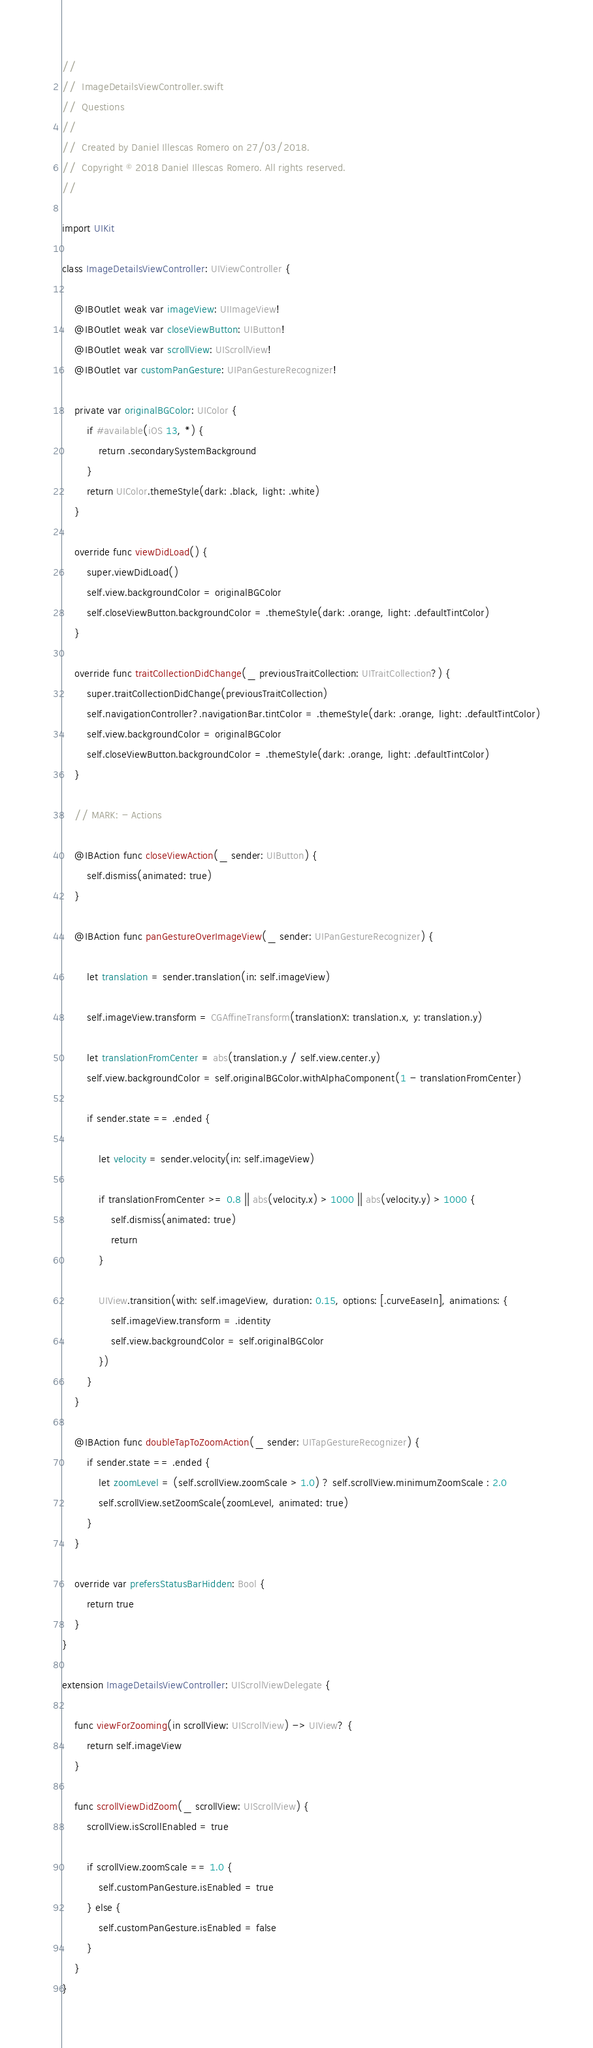<code> <loc_0><loc_0><loc_500><loc_500><_Swift_>//
//  ImageDetailsViewController.swift
//  Questions
//
//  Created by Daniel Illescas Romero on 27/03/2018.
//  Copyright © 2018 Daniel Illescas Romero. All rights reserved.
//

import UIKit

class ImageDetailsViewController: UIViewController {
	
	@IBOutlet weak var imageView: UIImageView!
	@IBOutlet weak var closeViewButton: UIButton!
	@IBOutlet weak var scrollView: UIScrollView!
	@IBOutlet var customPanGesture: UIPanGestureRecognizer!
	
	private var originalBGColor: UIColor {
		if #available(iOS 13, *) {
			return .secondarySystemBackground
		}
		return UIColor.themeStyle(dark: .black, light: .white)
	}
	
	override func viewDidLoad() {
		super.viewDidLoad()
		self.view.backgroundColor = originalBGColor
		self.closeViewButton.backgroundColor = .themeStyle(dark: .orange, light: .defaultTintColor)
	}
	
	override func traitCollectionDidChange(_ previousTraitCollection: UITraitCollection?) {
		super.traitCollectionDidChange(previousTraitCollection)
		self.navigationController?.navigationBar.tintColor = .themeStyle(dark: .orange, light: .defaultTintColor)
		self.view.backgroundColor = originalBGColor
		self.closeViewButton.backgroundColor = .themeStyle(dark: .orange, light: .defaultTintColor)
	}
	
	// MARK: - Actions
	
	@IBAction func closeViewAction(_ sender: UIButton) {
		self.dismiss(animated: true)
	}
	
	@IBAction func panGestureOverImageView(_ sender: UIPanGestureRecognizer) {
		
		let translation = sender.translation(in: self.imageView)
		
		self.imageView.transform = CGAffineTransform(translationX: translation.x, y: translation.y)
		
		let translationFromCenter = abs(translation.y / self.view.center.y)
		self.view.backgroundColor = self.originalBGColor.withAlphaComponent(1 - translationFromCenter)
		
		if sender.state == .ended {
			
			let velocity = sender.velocity(in: self.imageView)
			
			if translationFromCenter >= 0.8 || abs(velocity.x) > 1000 || abs(velocity.y) > 1000 {
				self.dismiss(animated: true)
				return
			}
			
			UIView.transition(with: self.imageView, duration: 0.15, options: [.curveEaseIn], animations: {
				self.imageView.transform = .identity
				self.view.backgroundColor = self.originalBGColor
			})
		}
	}
	
	@IBAction func doubleTapToZoomAction(_ sender: UITapGestureRecognizer) {
		if sender.state == .ended {
			let zoomLevel = (self.scrollView.zoomScale > 1.0) ? self.scrollView.minimumZoomScale : 2.0
			self.scrollView.setZoomScale(zoomLevel, animated: true)
		}
	}
	
	override var prefersStatusBarHidden: Bool {
		return true
	}
}

extension ImageDetailsViewController: UIScrollViewDelegate {
	
	func viewForZooming(in scrollView: UIScrollView) -> UIView? {
		return self.imageView
	}
	
	func scrollViewDidZoom(_ scrollView: UIScrollView) {
		scrollView.isScrollEnabled = true
		
		if scrollView.zoomScale == 1.0 {
			self.customPanGesture.isEnabled = true
		} else {
			self.customPanGesture.isEnabled = false
		}
	}
}
</code> 